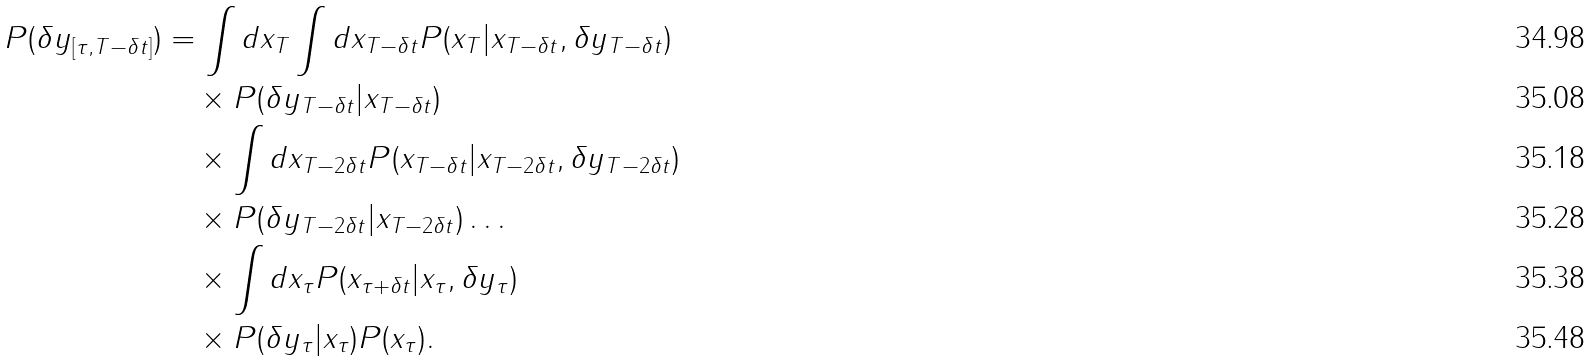<formula> <loc_0><loc_0><loc_500><loc_500>P ( \delta y _ { [ \tau , T - \delta t ] } ) & = \int d x _ { T } \int d x _ { T - \delta t } P ( x _ { T } | x _ { T - \delta t } , \delta y _ { T - \delta t } ) \\ & \quad \times P ( \delta y _ { T - \delta t } | x _ { T - \delta t } ) \\ & \quad \times \int d x _ { T - 2 \delta t } P ( x _ { T - \delta t } | x _ { T - 2 \delta t } , \delta y _ { T - 2 \delta t } ) \\ & \quad \times P ( \delta y _ { T - 2 \delta t } | x _ { T - 2 \delta t } ) \dots \\ & \quad \times \int d x _ { \tau } P ( x _ { \tau + \delta t } | x _ { \tau } , \delta y _ { \tau } ) \\ & \quad \times P ( \delta y _ { \tau } | x _ { \tau } ) P ( x _ { \tau } ) .</formula> 